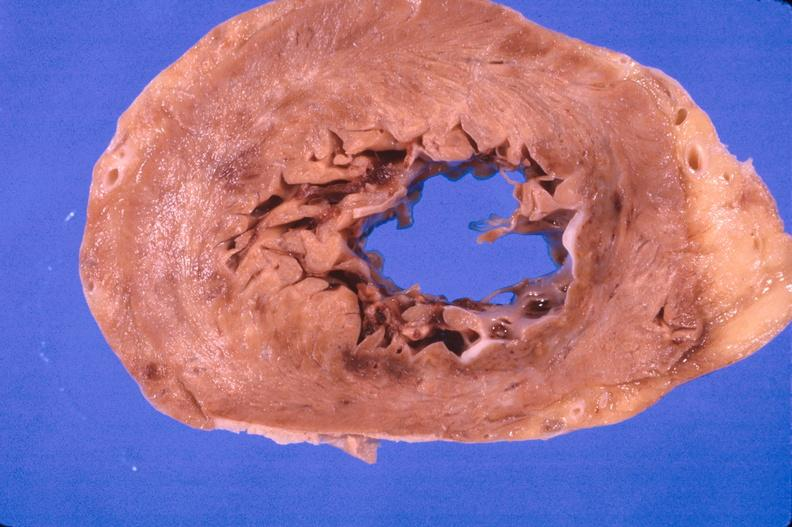what is present?
Answer the question using a single word or phrase. Cardiovascular 